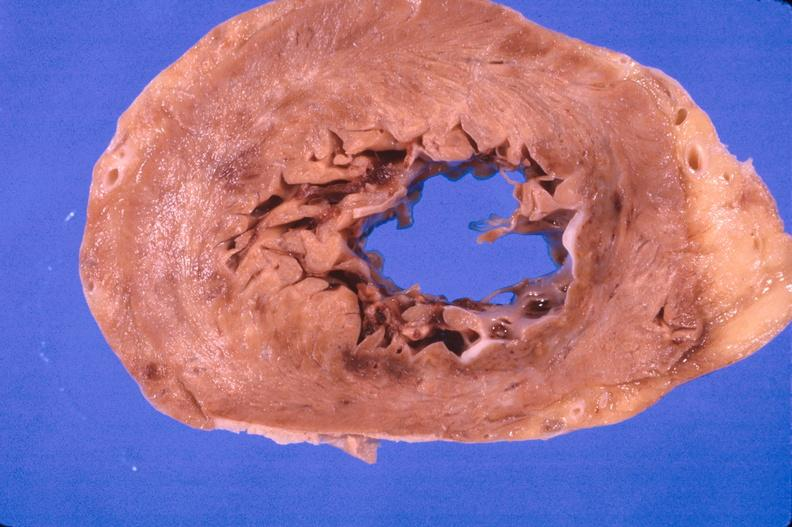what is present?
Answer the question using a single word or phrase. Cardiovascular 